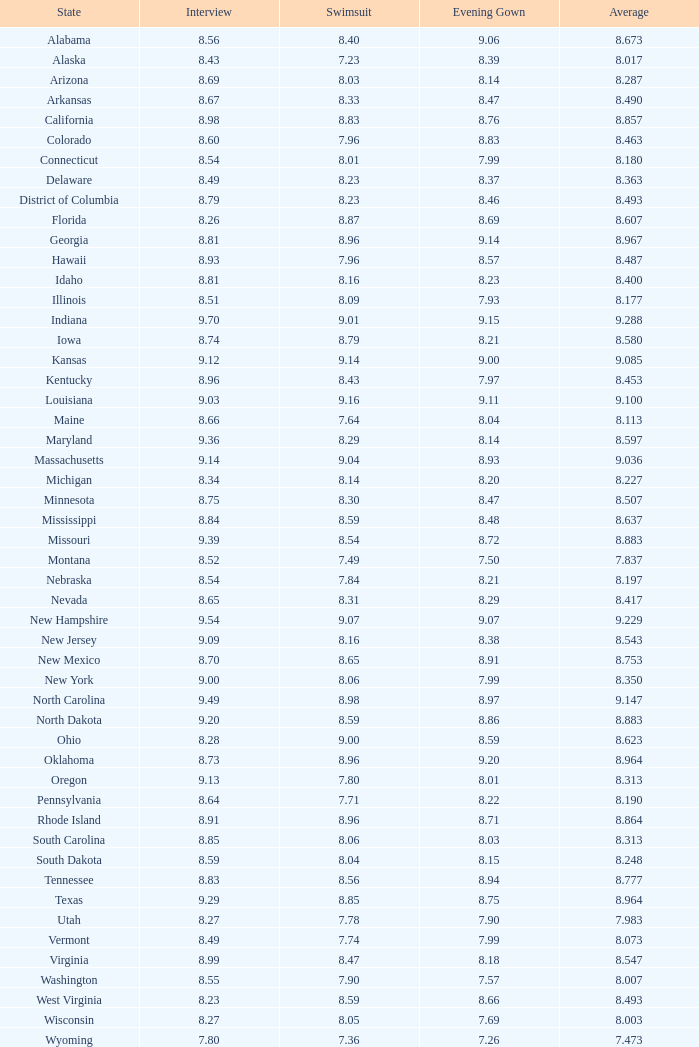0 1.0. 